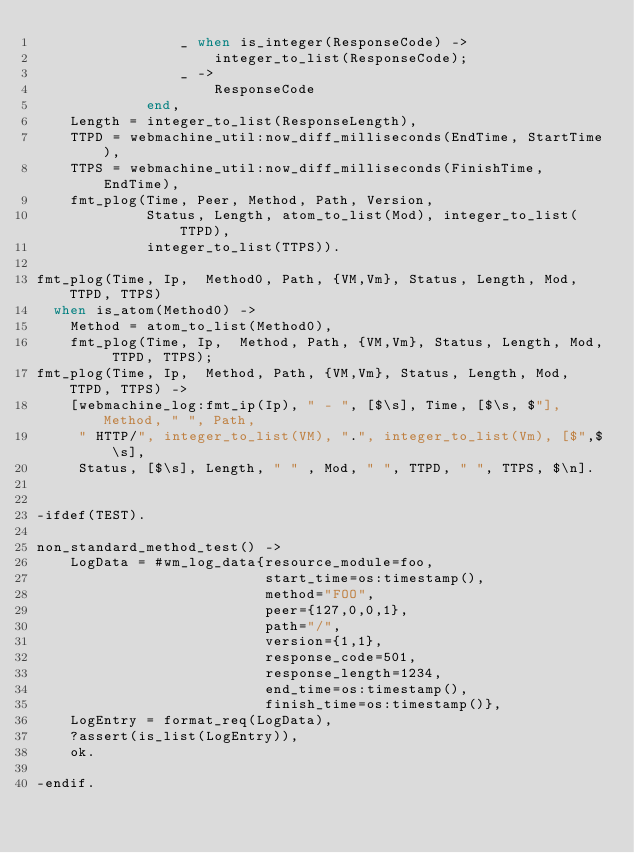<code> <loc_0><loc_0><loc_500><loc_500><_Erlang_>                 _ when is_integer(ResponseCode) ->
                     integer_to_list(ResponseCode);
                 _ ->
                     ResponseCode
             end,
    Length = integer_to_list(ResponseLength),
    TTPD = webmachine_util:now_diff_milliseconds(EndTime, StartTime),
    TTPS = webmachine_util:now_diff_milliseconds(FinishTime, EndTime),
    fmt_plog(Time, Peer, Method, Path, Version,
             Status, Length, atom_to_list(Mod), integer_to_list(TTPD),
             integer_to_list(TTPS)).

fmt_plog(Time, Ip,  Method0, Path, {VM,Vm}, Status, Length, Mod, TTPD, TTPS)
  when is_atom(Method0) ->
    Method = atom_to_list(Method0),
    fmt_plog(Time, Ip,  Method, Path, {VM,Vm}, Status, Length, Mod, TTPD, TTPS);
fmt_plog(Time, Ip,  Method, Path, {VM,Vm}, Status, Length, Mod, TTPD, TTPS) ->
    [webmachine_log:fmt_ip(Ip), " - ", [$\s], Time, [$\s, $"], Method, " ", Path,
     " HTTP/", integer_to_list(VM), ".", integer_to_list(Vm), [$",$\s],
     Status, [$\s], Length, " " , Mod, " ", TTPD, " ", TTPS, $\n].


-ifdef(TEST).

non_standard_method_test() ->
    LogData = #wm_log_data{resource_module=foo,
                           start_time=os:timestamp(),
                           method="FOO",
                           peer={127,0,0,1},
                           path="/",
                           version={1,1},
                           response_code=501,
                           response_length=1234,
                           end_time=os:timestamp(),
                           finish_time=os:timestamp()},
    LogEntry = format_req(LogData),
    ?assert(is_list(LogEntry)),
    ok.

-endif.
</code> 